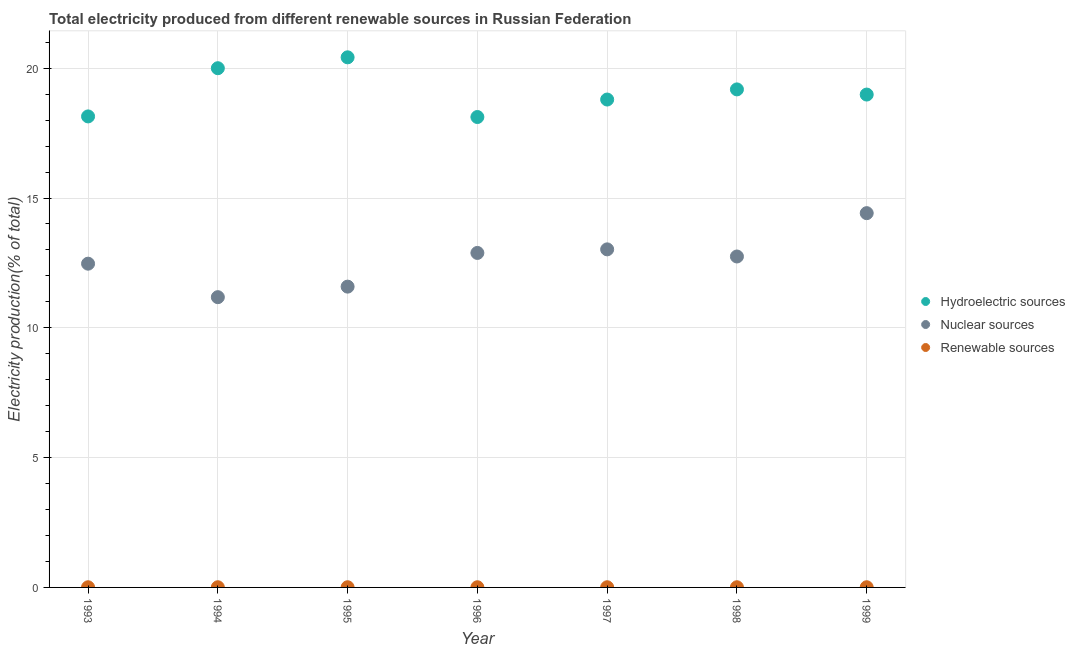Is the number of dotlines equal to the number of legend labels?
Provide a succinct answer. Yes. What is the percentage of electricity produced by renewable sources in 1993?
Make the answer very short. 0.01. Across all years, what is the maximum percentage of electricity produced by nuclear sources?
Keep it short and to the point. 14.42. Across all years, what is the minimum percentage of electricity produced by hydroelectric sources?
Your response must be concise. 18.12. In which year was the percentage of electricity produced by hydroelectric sources minimum?
Your answer should be very brief. 1996. What is the total percentage of electricity produced by nuclear sources in the graph?
Give a very brief answer. 88.31. What is the difference between the percentage of electricity produced by nuclear sources in 1995 and that in 1999?
Your response must be concise. -2.83. What is the difference between the percentage of electricity produced by hydroelectric sources in 1998 and the percentage of electricity produced by nuclear sources in 1995?
Your answer should be very brief. 7.6. What is the average percentage of electricity produced by nuclear sources per year?
Provide a short and direct response. 12.62. In the year 1999, what is the difference between the percentage of electricity produced by nuclear sources and percentage of electricity produced by renewable sources?
Your answer should be compact. 14.41. What is the ratio of the percentage of electricity produced by nuclear sources in 1993 to that in 1999?
Provide a short and direct response. 0.87. Is the percentage of electricity produced by hydroelectric sources in 1997 less than that in 1999?
Provide a short and direct response. Yes. What is the difference between the highest and the second highest percentage of electricity produced by nuclear sources?
Provide a short and direct response. 1.39. What is the difference between the highest and the lowest percentage of electricity produced by nuclear sources?
Make the answer very short. 3.24. Is the sum of the percentage of electricity produced by hydroelectric sources in 1994 and 1999 greater than the maximum percentage of electricity produced by nuclear sources across all years?
Keep it short and to the point. Yes. Is the percentage of electricity produced by renewable sources strictly greater than the percentage of electricity produced by nuclear sources over the years?
Your answer should be very brief. No. Is the percentage of electricity produced by nuclear sources strictly less than the percentage of electricity produced by hydroelectric sources over the years?
Your response must be concise. Yes. Does the graph contain any zero values?
Ensure brevity in your answer.  No. Does the graph contain grids?
Offer a terse response. Yes. How are the legend labels stacked?
Your answer should be very brief. Vertical. What is the title of the graph?
Give a very brief answer. Total electricity produced from different renewable sources in Russian Federation. What is the label or title of the X-axis?
Keep it short and to the point. Year. What is the label or title of the Y-axis?
Keep it short and to the point. Electricity production(% of total). What is the Electricity production(% of total) of Hydroelectric sources in 1993?
Keep it short and to the point. 18.14. What is the Electricity production(% of total) of Nuclear sources in 1993?
Your answer should be very brief. 12.47. What is the Electricity production(% of total) of Renewable sources in 1993?
Provide a succinct answer. 0.01. What is the Electricity production(% of total) in Hydroelectric sources in 1994?
Your answer should be very brief. 20. What is the Electricity production(% of total) in Nuclear sources in 1994?
Offer a very short reply. 11.18. What is the Electricity production(% of total) in Renewable sources in 1994?
Make the answer very short. 0.01. What is the Electricity production(% of total) of Hydroelectric sources in 1995?
Give a very brief answer. 20.42. What is the Electricity production(% of total) of Nuclear sources in 1995?
Your response must be concise. 11.59. What is the Electricity production(% of total) of Renewable sources in 1995?
Your answer should be very brief. 0.01. What is the Electricity production(% of total) in Hydroelectric sources in 1996?
Give a very brief answer. 18.12. What is the Electricity production(% of total) of Nuclear sources in 1996?
Make the answer very short. 12.88. What is the Electricity production(% of total) of Renewable sources in 1996?
Provide a short and direct response. 0.01. What is the Electricity production(% of total) in Hydroelectric sources in 1997?
Give a very brief answer. 18.79. What is the Electricity production(% of total) in Nuclear sources in 1997?
Offer a very short reply. 13.02. What is the Electricity production(% of total) of Renewable sources in 1997?
Offer a very short reply. 0.01. What is the Electricity production(% of total) of Hydroelectric sources in 1998?
Provide a succinct answer. 19.18. What is the Electricity production(% of total) in Nuclear sources in 1998?
Offer a very short reply. 12.75. What is the Electricity production(% of total) in Renewable sources in 1998?
Provide a succinct answer. 0.01. What is the Electricity production(% of total) of Hydroelectric sources in 1999?
Make the answer very short. 18.99. What is the Electricity production(% of total) in Nuclear sources in 1999?
Offer a very short reply. 14.42. What is the Electricity production(% of total) in Renewable sources in 1999?
Offer a terse response. 0.01. Across all years, what is the maximum Electricity production(% of total) of Hydroelectric sources?
Offer a very short reply. 20.42. Across all years, what is the maximum Electricity production(% of total) in Nuclear sources?
Provide a succinct answer. 14.42. Across all years, what is the maximum Electricity production(% of total) of Renewable sources?
Make the answer very short. 0.01. Across all years, what is the minimum Electricity production(% of total) of Hydroelectric sources?
Provide a short and direct response. 18.12. Across all years, what is the minimum Electricity production(% of total) of Nuclear sources?
Your response must be concise. 11.18. Across all years, what is the minimum Electricity production(% of total) of Renewable sources?
Give a very brief answer. 0.01. What is the total Electricity production(% of total) in Hydroelectric sources in the graph?
Provide a short and direct response. 133.65. What is the total Electricity production(% of total) of Nuclear sources in the graph?
Ensure brevity in your answer.  88.31. What is the total Electricity production(% of total) in Renewable sources in the graph?
Offer a very short reply. 0.05. What is the difference between the Electricity production(% of total) of Hydroelectric sources in 1993 and that in 1994?
Offer a terse response. -1.86. What is the difference between the Electricity production(% of total) in Nuclear sources in 1993 and that in 1994?
Make the answer very short. 1.29. What is the difference between the Electricity production(% of total) in Renewable sources in 1993 and that in 1994?
Ensure brevity in your answer.  -0. What is the difference between the Electricity production(% of total) of Hydroelectric sources in 1993 and that in 1995?
Your answer should be compact. -2.28. What is the difference between the Electricity production(% of total) of Nuclear sources in 1993 and that in 1995?
Ensure brevity in your answer.  0.88. What is the difference between the Electricity production(% of total) in Renewable sources in 1993 and that in 1995?
Provide a succinct answer. -0. What is the difference between the Electricity production(% of total) of Hydroelectric sources in 1993 and that in 1996?
Provide a succinct answer. 0.02. What is the difference between the Electricity production(% of total) in Nuclear sources in 1993 and that in 1996?
Your response must be concise. -0.41. What is the difference between the Electricity production(% of total) in Renewable sources in 1993 and that in 1996?
Ensure brevity in your answer.  -0. What is the difference between the Electricity production(% of total) in Hydroelectric sources in 1993 and that in 1997?
Offer a very short reply. -0.65. What is the difference between the Electricity production(% of total) of Nuclear sources in 1993 and that in 1997?
Make the answer very short. -0.55. What is the difference between the Electricity production(% of total) in Renewable sources in 1993 and that in 1997?
Your answer should be compact. -0. What is the difference between the Electricity production(% of total) of Hydroelectric sources in 1993 and that in 1998?
Offer a terse response. -1.04. What is the difference between the Electricity production(% of total) in Nuclear sources in 1993 and that in 1998?
Provide a short and direct response. -0.28. What is the difference between the Electricity production(% of total) in Renewable sources in 1993 and that in 1998?
Offer a terse response. -0. What is the difference between the Electricity production(% of total) of Hydroelectric sources in 1993 and that in 1999?
Offer a very short reply. -0.84. What is the difference between the Electricity production(% of total) in Nuclear sources in 1993 and that in 1999?
Offer a terse response. -1.95. What is the difference between the Electricity production(% of total) of Renewable sources in 1993 and that in 1999?
Ensure brevity in your answer.  -0. What is the difference between the Electricity production(% of total) in Hydroelectric sources in 1994 and that in 1995?
Your answer should be very brief. -0.42. What is the difference between the Electricity production(% of total) of Nuclear sources in 1994 and that in 1995?
Your answer should be very brief. -0.41. What is the difference between the Electricity production(% of total) of Renewable sources in 1994 and that in 1995?
Provide a short and direct response. 0. What is the difference between the Electricity production(% of total) of Hydroelectric sources in 1994 and that in 1996?
Your answer should be very brief. 1.88. What is the difference between the Electricity production(% of total) in Nuclear sources in 1994 and that in 1996?
Keep it short and to the point. -1.7. What is the difference between the Electricity production(% of total) of Hydroelectric sources in 1994 and that in 1997?
Keep it short and to the point. 1.21. What is the difference between the Electricity production(% of total) of Nuclear sources in 1994 and that in 1997?
Give a very brief answer. -1.84. What is the difference between the Electricity production(% of total) in Hydroelectric sources in 1994 and that in 1998?
Make the answer very short. 0.82. What is the difference between the Electricity production(% of total) in Nuclear sources in 1994 and that in 1998?
Give a very brief answer. -1.57. What is the difference between the Electricity production(% of total) of Hydroelectric sources in 1994 and that in 1999?
Your answer should be compact. 1.01. What is the difference between the Electricity production(% of total) in Nuclear sources in 1994 and that in 1999?
Your response must be concise. -3.24. What is the difference between the Electricity production(% of total) of Renewable sources in 1994 and that in 1999?
Give a very brief answer. -0. What is the difference between the Electricity production(% of total) of Hydroelectric sources in 1995 and that in 1996?
Give a very brief answer. 2.3. What is the difference between the Electricity production(% of total) in Nuclear sources in 1995 and that in 1996?
Give a very brief answer. -1.3. What is the difference between the Electricity production(% of total) of Hydroelectric sources in 1995 and that in 1997?
Offer a very short reply. 1.63. What is the difference between the Electricity production(% of total) of Nuclear sources in 1995 and that in 1997?
Keep it short and to the point. -1.44. What is the difference between the Electricity production(% of total) in Renewable sources in 1995 and that in 1997?
Provide a succinct answer. 0. What is the difference between the Electricity production(% of total) in Hydroelectric sources in 1995 and that in 1998?
Your answer should be very brief. 1.24. What is the difference between the Electricity production(% of total) of Nuclear sources in 1995 and that in 1998?
Keep it short and to the point. -1.16. What is the difference between the Electricity production(% of total) in Renewable sources in 1995 and that in 1998?
Provide a short and direct response. -0. What is the difference between the Electricity production(% of total) of Hydroelectric sources in 1995 and that in 1999?
Offer a terse response. 1.43. What is the difference between the Electricity production(% of total) in Nuclear sources in 1995 and that in 1999?
Ensure brevity in your answer.  -2.83. What is the difference between the Electricity production(% of total) of Renewable sources in 1995 and that in 1999?
Your answer should be very brief. -0. What is the difference between the Electricity production(% of total) of Hydroelectric sources in 1996 and that in 1997?
Offer a terse response. -0.67. What is the difference between the Electricity production(% of total) in Nuclear sources in 1996 and that in 1997?
Your response must be concise. -0.14. What is the difference between the Electricity production(% of total) in Renewable sources in 1996 and that in 1997?
Provide a short and direct response. -0. What is the difference between the Electricity production(% of total) of Hydroelectric sources in 1996 and that in 1998?
Your answer should be compact. -1.06. What is the difference between the Electricity production(% of total) in Nuclear sources in 1996 and that in 1998?
Make the answer very short. 0.14. What is the difference between the Electricity production(% of total) in Renewable sources in 1996 and that in 1998?
Provide a succinct answer. -0. What is the difference between the Electricity production(% of total) in Hydroelectric sources in 1996 and that in 1999?
Your answer should be very brief. -0.86. What is the difference between the Electricity production(% of total) of Nuclear sources in 1996 and that in 1999?
Make the answer very short. -1.53. What is the difference between the Electricity production(% of total) of Renewable sources in 1996 and that in 1999?
Provide a short and direct response. -0. What is the difference between the Electricity production(% of total) of Hydroelectric sources in 1997 and that in 1998?
Offer a very short reply. -0.39. What is the difference between the Electricity production(% of total) of Nuclear sources in 1997 and that in 1998?
Make the answer very short. 0.27. What is the difference between the Electricity production(% of total) in Renewable sources in 1997 and that in 1998?
Your response must be concise. -0. What is the difference between the Electricity production(% of total) in Hydroelectric sources in 1997 and that in 1999?
Offer a very short reply. -0.19. What is the difference between the Electricity production(% of total) in Nuclear sources in 1997 and that in 1999?
Provide a succinct answer. -1.39. What is the difference between the Electricity production(% of total) of Renewable sources in 1997 and that in 1999?
Your answer should be very brief. -0. What is the difference between the Electricity production(% of total) in Hydroelectric sources in 1998 and that in 1999?
Your answer should be compact. 0.2. What is the difference between the Electricity production(% of total) in Nuclear sources in 1998 and that in 1999?
Give a very brief answer. -1.67. What is the difference between the Electricity production(% of total) of Renewable sources in 1998 and that in 1999?
Make the answer very short. -0. What is the difference between the Electricity production(% of total) of Hydroelectric sources in 1993 and the Electricity production(% of total) of Nuclear sources in 1994?
Give a very brief answer. 6.96. What is the difference between the Electricity production(% of total) of Hydroelectric sources in 1993 and the Electricity production(% of total) of Renewable sources in 1994?
Keep it short and to the point. 18.14. What is the difference between the Electricity production(% of total) in Nuclear sources in 1993 and the Electricity production(% of total) in Renewable sources in 1994?
Your answer should be very brief. 12.46. What is the difference between the Electricity production(% of total) in Hydroelectric sources in 1993 and the Electricity production(% of total) in Nuclear sources in 1995?
Make the answer very short. 6.56. What is the difference between the Electricity production(% of total) in Hydroelectric sources in 1993 and the Electricity production(% of total) in Renewable sources in 1995?
Provide a short and direct response. 18.14. What is the difference between the Electricity production(% of total) of Nuclear sources in 1993 and the Electricity production(% of total) of Renewable sources in 1995?
Provide a short and direct response. 12.46. What is the difference between the Electricity production(% of total) of Hydroelectric sources in 1993 and the Electricity production(% of total) of Nuclear sources in 1996?
Your response must be concise. 5.26. What is the difference between the Electricity production(% of total) in Hydroelectric sources in 1993 and the Electricity production(% of total) in Renewable sources in 1996?
Your answer should be compact. 18.14. What is the difference between the Electricity production(% of total) in Nuclear sources in 1993 and the Electricity production(% of total) in Renewable sources in 1996?
Your answer should be very brief. 12.46. What is the difference between the Electricity production(% of total) in Hydroelectric sources in 1993 and the Electricity production(% of total) in Nuclear sources in 1997?
Ensure brevity in your answer.  5.12. What is the difference between the Electricity production(% of total) of Hydroelectric sources in 1993 and the Electricity production(% of total) of Renewable sources in 1997?
Your answer should be compact. 18.14. What is the difference between the Electricity production(% of total) in Nuclear sources in 1993 and the Electricity production(% of total) in Renewable sources in 1997?
Ensure brevity in your answer.  12.46. What is the difference between the Electricity production(% of total) in Hydroelectric sources in 1993 and the Electricity production(% of total) in Nuclear sources in 1998?
Make the answer very short. 5.4. What is the difference between the Electricity production(% of total) in Hydroelectric sources in 1993 and the Electricity production(% of total) in Renewable sources in 1998?
Provide a succinct answer. 18.14. What is the difference between the Electricity production(% of total) in Nuclear sources in 1993 and the Electricity production(% of total) in Renewable sources in 1998?
Provide a short and direct response. 12.46. What is the difference between the Electricity production(% of total) of Hydroelectric sources in 1993 and the Electricity production(% of total) of Nuclear sources in 1999?
Your answer should be very brief. 3.73. What is the difference between the Electricity production(% of total) in Hydroelectric sources in 1993 and the Electricity production(% of total) in Renewable sources in 1999?
Provide a succinct answer. 18.14. What is the difference between the Electricity production(% of total) of Nuclear sources in 1993 and the Electricity production(% of total) of Renewable sources in 1999?
Make the answer very short. 12.46. What is the difference between the Electricity production(% of total) of Hydroelectric sources in 1994 and the Electricity production(% of total) of Nuclear sources in 1995?
Give a very brief answer. 8.41. What is the difference between the Electricity production(% of total) in Hydroelectric sources in 1994 and the Electricity production(% of total) in Renewable sources in 1995?
Your answer should be very brief. 19.99. What is the difference between the Electricity production(% of total) of Nuclear sources in 1994 and the Electricity production(% of total) of Renewable sources in 1995?
Ensure brevity in your answer.  11.17. What is the difference between the Electricity production(% of total) of Hydroelectric sources in 1994 and the Electricity production(% of total) of Nuclear sources in 1996?
Ensure brevity in your answer.  7.12. What is the difference between the Electricity production(% of total) in Hydroelectric sources in 1994 and the Electricity production(% of total) in Renewable sources in 1996?
Provide a succinct answer. 19.99. What is the difference between the Electricity production(% of total) of Nuclear sources in 1994 and the Electricity production(% of total) of Renewable sources in 1996?
Give a very brief answer. 11.17. What is the difference between the Electricity production(% of total) of Hydroelectric sources in 1994 and the Electricity production(% of total) of Nuclear sources in 1997?
Your answer should be very brief. 6.98. What is the difference between the Electricity production(% of total) in Hydroelectric sources in 1994 and the Electricity production(% of total) in Renewable sources in 1997?
Your answer should be compact. 19.99. What is the difference between the Electricity production(% of total) of Nuclear sources in 1994 and the Electricity production(% of total) of Renewable sources in 1997?
Make the answer very short. 11.17. What is the difference between the Electricity production(% of total) in Hydroelectric sources in 1994 and the Electricity production(% of total) in Nuclear sources in 1998?
Provide a short and direct response. 7.25. What is the difference between the Electricity production(% of total) in Hydroelectric sources in 1994 and the Electricity production(% of total) in Renewable sources in 1998?
Offer a terse response. 19.99. What is the difference between the Electricity production(% of total) of Nuclear sources in 1994 and the Electricity production(% of total) of Renewable sources in 1998?
Make the answer very short. 11.17. What is the difference between the Electricity production(% of total) of Hydroelectric sources in 1994 and the Electricity production(% of total) of Nuclear sources in 1999?
Make the answer very short. 5.58. What is the difference between the Electricity production(% of total) in Hydroelectric sources in 1994 and the Electricity production(% of total) in Renewable sources in 1999?
Keep it short and to the point. 19.99. What is the difference between the Electricity production(% of total) in Nuclear sources in 1994 and the Electricity production(% of total) in Renewable sources in 1999?
Offer a terse response. 11.17. What is the difference between the Electricity production(% of total) in Hydroelectric sources in 1995 and the Electricity production(% of total) in Nuclear sources in 1996?
Keep it short and to the point. 7.54. What is the difference between the Electricity production(% of total) of Hydroelectric sources in 1995 and the Electricity production(% of total) of Renewable sources in 1996?
Your answer should be compact. 20.41. What is the difference between the Electricity production(% of total) in Nuclear sources in 1995 and the Electricity production(% of total) in Renewable sources in 1996?
Ensure brevity in your answer.  11.58. What is the difference between the Electricity production(% of total) of Hydroelectric sources in 1995 and the Electricity production(% of total) of Nuclear sources in 1997?
Your answer should be very brief. 7.4. What is the difference between the Electricity production(% of total) of Hydroelectric sources in 1995 and the Electricity production(% of total) of Renewable sources in 1997?
Provide a succinct answer. 20.41. What is the difference between the Electricity production(% of total) of Nuclear sources in 1995 and the Electricity production(% of total) of Renewable sources in 1997?
Your answer should be compact. 11.58. What is the difference between the Electricity production(% of total) of Hydroelectric sources in 1995 and the Electricity production(% of total) of Nuclear sources in 1998?
Give a very brief answer. 7.67. What is the difference between the Electricity production(% of total) in Hydroelectric sources in 1995 and the Electricity production(% of total) in Renewable sources in 1998?
Ensure brevity in your answer.  20.41. What is the difference between the Electricity production(% of total) in Nuclear sources in 1995 and the Electricity production(% of total) in Renewable sources in 1998?
Provide a short and direct response. 11.58. What is the difference between the Electricity production(% of total) in Hydroelectric sources in 1995 and the Electricity production(% of total) in Nuclear sources in 1999?
Give a very brief answer. 6. What is the difference between the Electricity production(% of total) of Hydroelectric sources in 1995 and the Electricity production(% of total) of Renewable sources in 1999?
Give a very brief answer. 20.41. What is the difference between the Electricity production(% of total) of Nuclear sources in 1995 and the Electricity production(% of total) of Renewable sources in 1999?
Keep it short and to the point. 11.58. What is the difference between the Electricity production(% of total) in Hydroelectric sources in 1996 and the Electricity production(% of total) in Nuclear sources in 1997?
Make the answer very short. 5.1. What is the difference between the Electricity production(% of total) of Hydroelectric sources in 1996 and the Electricity production(% of total) of Renewable sources in 1997?
Keep it short and to the point. 18.11. What is the difference between the Electricity production(% of total) of Nuclear sources in 1996 and the Electricity production(% of total) of Renewable sources in 1997?
Ensure brevity in your answer.  12.88. What is the difference between the Electricity production(% of total) in Hydroelectric sources in 1996 and the Electricity production(% of total) in Nuclear sources in 1998?
Your answer should be compact. 5.37. What is the difference between the Electricity production(% of total) of Hydroelectric sources in 1996 and the Electricity production(% of total) of Renewable sources in 1998?
Give a very brief answer. 18.11. What is the difference between the Electricity production(% of total) in Nuclear sources in 1996 and the Electricity production(% of total) in Renewable sources in 1998?
Provide a succinct answer. 12.88. What is the difference between the Electricity production(% of total) in Hydroelectric sources in 1996 and the Electricity production(% of total) in Nuclear sources in 1999?
Offer a terse response. 3.7. What is the difference between the Electricity production(% of total) in Hydroelectric sources in 1996 and the Electricity production(% of total) in Renewable sources in 1999?
Provide a short and direct response. 18.11. What is the difference between the Electricity production(% of total) in Nuclear sources in 1996 and the Electricity production(% of total) in Renewable sources in 1999?
Provide a short and direct response. 12.88. What is the difference between the Electricity production(% of total) of Hydroelectric sources in 1997 and the Electricity production(% of total) of Nuclear sources in 1998?
Your response must be concise. 6.05. What is the difference between the Electricity production(% of total) of Hydroelectric sources in 1997 and the Electricity production(% of total) of Renewable sources in 1998?
Provide a succinct answer. 18.79. What is the difference between the Electricity production(% of total) of Nuclear sources in 1997 and the Electricity production(% of total) of Renewable sources in 1998?
Give a very brief answer. 13.02. What is the difference between the Electricity production(% of total) of Hydroelectric sources in 1997 and the Electricity production(% of total) of Nuclear sources in 1999?
Your response must be concise. 4.38. What is the difference between the Electricity production(% of total) in Hydroelectric sources in 1997 and the Electricity production(% of total) in Renewable sources in 1999?
Your response must be concise. 18.79. What is the difference between the Electricity production(% of total) of Nuclear sources in 1997 and the Electricity production(% of total) of Renewable sources in 1999?
Make the answer very short. 13.02. What is the difference between the Electricity production(% of total) in Hydroelectric sources in 1998 and the Electricity production(% of total) in Nuclear sources in 1999?
Offer a very short reply. 4.77. What is the difference between the Electricity production(% of total) in Hydroelectric sources in 1998 and the Electricity production(% of total) in Renewable sources in 1999?
Make the answer very short. 19.18. What is the difference between the Electricity production(% of total) of Nuclear sources in 1998 and the Electricity production(% of total) of Renewable sources in 1999?
Ensure brevity in your answer.  12.74. What is the average Electricity production(% of total) of Hydroelectric sources per year?
Keep it short and to the point. 19.09. What is the average Electricity production(% of total) in Nuclear sources per year?
Keep it short and to the point. 12.62. What is the average Electricity production(% of total) in Renewable sources per year?
Offer a terse response. 0.01. In the year 1993, what is the difference between the Electricity production(% of total) in Hydroelectric sources and Electricity production(% of total) in Nuclear sources?
Your response must be concise. 5.67. In the year 1993, what is the difference between the Electricity production(% of total) of Hydroelectric sources and Electricity production(% of total) of Renewable sources?
Provide a short and direct response. 18.14. In the year 1993, what is the difference between the Electricity production(% of total) of Nuclear sources and Electricity production(% of total) of Renewable sources?
Offer a very short reply. 12.46. In the year 1994, what is the difference between the Electricity production(% of total) in Hydroelectric sources and Electricity production(% of total) in Nuclear sources?
Your answer should be compact. 8.82. In the year 1994, what is the difference between the Electricity production(% of total) of Hydroelectric sources and Electricity production(% of total) of Renewable sources?
Your response must be concise. 19.99. In the year 1994, what is the difference between the Electricity production(% of total) of Nuclear sources and Electricity production(% of total) of Renewable sources?
Provide a succinct answer. 11.17. In the year 1995, what is the difference between the Electricity production(% of total) of Hydroelectric sources and Electricity production(% of total) of Nuclear sources?
Provide a succinct answer. 8.83. In the year 1995, what is the difference between the Electricity production(% of total) in Hydroelectric sources and Electricity production(% of total) in Renewable sources?
Give a very brief answer. 20.41. In the year 1995, what is the difference between the Electricity production(% of total) in Nuclear sources and Electricity production(% of total) in Renewable sources?
Ensure brevity in your answer.  11.58. In the year 1996, what is the difference between the Electricity production(% of total) in Hydroelectric sources and Electricity production(% of total) in Nuclear sources?
Your answer should be compact. 5.24. In the year 1996, what is the difference between the Electricity production(% of total) in Hydroelectric sources and Electricity production(% of total) in Renewable sources?
Provide a succinct answer. 18.11. In the year 1996, what is the difference between the Electricity production(% of total) of Nuclear sources and Electricity production(% of total) of Renewable sources?
Offer a very short reply. 12.88. In the year 1997, what is the difference between the Electricity production(% of total) in Hydroelectric sources and Electricity production(% of total) in Nuclear sources?
Your answer should be very brief. 5.77. In the year 1997, what is the difference between the Electricity production(% of total) of Hydroelectric sources and Electricity production(% of total) of Renewable sources?
Keep it short and to the point. 18.79. In the year 1997, what is the difference between the Electricity production(% of total) in Nuclear sources and Electricity production(% of total) in Renewable sources?
Offer a terse response. 13.02. In the year 1998, what is the difference between the Electricity production(% of total) in Hydroelectric sources and Electricity production(% of total) in Nuclear sources?
Your response must be concise. 6.44. In the year 1998, what is the difference between the Electricity production(% of total) of Hydroelectric sources and Electricity production(% of total) of Renewable sources?
Make the answer very short. 19.18. In the year 1998, what is the difference between the Electricity production(% of total) of Nuclear sources and Electricity production(% of total) of Renewable sources?
Ensure brevity in your answer.  12.74. In the year 1999, what is the difference between the Electricity production(% of total) of Hydroelectric sources and Electricity production(% of total) of Nuclear sources?
Provide a short and direct response. 4.57. In the year 1999, what is the difference between the Electricity production(% of total) in Hydroelectric sources and Electricity production(% of total) in Renewable sources?
Offer a terse response. 18.98. In the year 1999, what is the difference between the Electricity production(% of total) of Nuclear sources and Electricity production(% of total) of Renewable sources?
Your response must be concise. 14.41. What is the ratio of the Electricity production(% of total) of Hydroelectric sources in 1993 to that in 1994?
Keep it short and to the point. 0.91. What is the ratio of the Electricity production(% of total) in Nuclear sources in 1993 to that in 1994?
Give a very brief answer. 1.12. What is the ratio of the Electricity production(% of total) in Renewable sources in 1993 to that in 1994?
Offer a very short reply. 0.9. What is the ratio of the Electricity production(% of total) in Hydroelectric sources in 1993 to that in 1995?
Keep it short and to the point. 0.89. What is the ratio of the Electricity production(% of total) in Nuclear sources in 1993 to that in 1995?
Ensure brevity in your answer.  1.08. What is the ratio of the Electricity production(% of total) of Renewable sources in 1993 to that in 1995?
Ensure brevity in your answer.  0.91. What is the ratio of the Electricity production(% of total) of Nuclear sources in 1993 to that in 1996?
Keep it short and to the point. 0.97. What is the ratio of the Electricity production(% of total) of Renewable sources in 1993 to that in 1996?
Ensure brevity in your answer.  0.93. What is the ratio of the Electricity production(% of total) of Hydroelectric sources in 1993 to that in 1997?
Keep it short and to the point. 0.97. What is the ratio of the Electricity production(% of total) in Nuclear sources in 1993 to that in 1997?
Provide a succinct answer. 0.96. What is the ratio of the Electricity production(% of total) of Renewable sources in 1993 to that in 1997?
Provide a short and direct response. 0.92. What is the ratio of the Electricity production(% of total) in Hydroelectric sources in 1993 to that in 1998?
Keep it short and to the point. 0.95. What is the ratio of the Electricity production(% of total) in Nuclear sources in 1993 to that in 1998?
Keep it short and to the point. 0.98. What is the ratio of the Electricity production(% of total) in Renewable sources in 1993 to that in 1998?
Offer a very short reply. 0.89. What is the ratio of the Electricity production(% of total) of Hydroelectric sources in 1993 to that in 1999?
Your answer should be very brief. 0.96. What is the ratio of the Electricity production(% of total) of Nuclear sources in 1993 to that in 1999?
Your answer should be very brief. 0.86. What is the ratio of the Electricity production(% of total) in Renewable sources in 1993 to that in 1999?
Your answer should be compact. 0.88. What is the ratio of the Electricity production(% of total) of Hydroelectric sources in 1994 to that in 1995?
Make the answer very short. 0.98. What is the ratio of the Electricity production(% of total) in Nuclear sources in 1994 to that in 1995?
Make the answer very short. 0.96. What is the ratio of the Electricity production(% of total) of Renewable sources in 1994 to that in 1995?
Provide a short and direct response. 1.02. What is the ratio of the Electricity production(% of total) in Hydroelectric sources in 1994 to that in 1996?
Offer a very short reply. 1.1. What is the ratio of the Electricity production(% of total) in Nuclear sources in 1994 to that in 1996?
Give a very brief answer. 0.87. What is the ratio of the Electricity production(% of total) in Renewable sources in 1994 to that in 1996?
Your answer should be compact. 1.04. What is the ratio of the Electricity production(% of total) in Hydroelectric sources in 1994 to that in 1997?
Your response must be concise. 1.06. What is the ratio of the Electricity production(% of total) in Nuclear sources in 1994 to that in 1997?
Provide a succinct answer. 0.86. What is the ratio of the Electricity production(% of total) in Renewable sources in 1994 to that in 1997?
Give a very brief answer. 1.02. What is the ratio of the Electricity production(% of total) in Hydroelectric sources in 1994 to that in 1998?
Your answer should be compact. 1.04. What is the ratio of the Electricity production(% of total) of Nuclear sources in 1994 to that in 1998?
Give a very brief answer. 0.88. What is the ratio of the Electricity production(% of total) in Hydroelectric sources in 1994 to that in 1999?
Give a very brief answer. 1.05. What is the ratio of the Electricity production(% of total) of Nuclear sources in 1994 to that in 1999?
Make the answer very short. 0.78. What is the ratio of the Electricity production(% of total) of Renewable sources in 1994 to that in 1999?
Your response must be concise. 0.98. What is the ratio of the Electricity production(% of total) in Hydroelectric sources in 1995 to that in 1996?
Give a very brief answer. 1.13. What is the ratio of the Electricity production(% of total) of Nuclear sources in 1995 to that in 1996?
Your response must be concise. 0.9. What is the ratio of the Electricity production(% of total) in Renewable sources in 1995 to that in 1996?
Make the answer very short. 1.02. What is the ratio of the Electricity production(% of total) in Hydroelectric sources in 1995 to that in 1997?
Ensure brevity in your answer.  1.09. What is the ratio of the Electricity production(% of total) in Nuclear sources in 1995 to that in 1997?
Make the answer very short. 0.89. What is the ratio of the Electricity production(% of total) in Hydroelectric sources in 1995 to that in 1998?
Your answer should be very brief. 1.06. What is the ratio of the Electricity production(% of total) in Nuclear sources in 1995 to that in 1998?
Keep it short and to the point. 0.91. What is the ratio of the Electricity production(% of total) of Renewable sources in 1995 to that in 1998?
Your answer should be compact. 0.98. What is the ratio of the Electricity production(% of total) of Hydroelectric sources in 1995 to that in 1999?
Your answer should be very brief. 1.08. What is the ratio of the Electricity production(% of total) of Nuclear sources in 1995 to that in 1999?
Your answer should be very brief. 0.8. What is the ratio of the Electricity production(% of total) of Renewable sources in 1995 to that in 1999?
Ensure brevity in your answer.  0.97. What is the ratio of the Electricity production(% of total) of Hydroelectric sources in 1996 to that in 1997?
Give a very brief answer. 0.96. What is the ratio of the Electricity production(% of total) of Nuclear sources in 1996 to that in 1997?
Your answer should be compact. 0.99. What is the ratio of the Electricity production(% of total) in Renewable sources in 1996 to that in 1997?
Make the answer very short. 0.98. What is the ratio of the Electricity production(% of total) in Hydroelectric sources in 1996 to that in 1998?
Your answer should be compact. 0.94. What is the ratio of the Electricity production(% of total) in Nuclear sources in 1996 to that in 1998?
Keep it short and to the point. 1.01. What is the ratio of the Electricity production(% of total) in Renewable sources in 1996 to that in 1998?
Offer a very short reply. 0.96. What is the ratio of the Electricity production(% of total) of Hydroelectric sources in 1996 to that in 1999?
Provide a short and direct response. 0.95. What is the ratio of the Electricity production(% of total) of Nuclear sources in 1996 to that in 1999?
Keep it short and to the point. 0.89. What is the ratio of the Electricity production(% of total) of Renewable sources in 1996 to that in 1999?
Ensure brevity in your answer.  0.95. What is the ratio of the Electricity production(% of total) of Hydroelectric sources in 1997 to that in 1998?
Give a very brief answer. 0.98. What is the ratio of the Electricity production(% of total) in Nuclear sources in 1997 to that in 1998?
Ensure brevity in your answer.  1.02. What is the ratio of the Electricity production(% of total) of Renewable sources in 1997 to that in 1998?
Ensure brevity in your answer.  0.97. What is the ratio of the Electricity production(% of total) of Hydroelectric sources in 1997 to that in 1999?
Give a very brief answer. 0.99. What is the ratio of the Electricity production(% of total) of Nuclear sources in 1997 to that in 1999?
Your answer should be very brief. 0.9. What is the ratio of the Electricity production(% of total) in Renewable sources in 1997 to that in 1999?
Provide a short and direct response. 0.96. What is the ratio of the Electricity production(% of total) of Hydroelectric sources in 1998 to that in 1999?
Your answer should be compact. 1.01. What is the ratio of the Electricity production(% of total) in Nuclear sources in 1998 to that in 1999?
Keep it short and to the point. 0.88. What is the ratio of the Electricity production(% of total) of Renewable sources in 1998 to that in 1999?
Offer a very short reply. 0.99. What is the difference between the highest and the second highest Electricity production(% of total) of Hydroelectric sources?
Provide a succinct answer. 0.42. What is the difference between the highest and the second highest Electricity production(% of total) of Nuclear sources?
Keep it short and to the point. 1.39. What is the difference between the highest and the lowest Electricity production(% of total) in Hydroelectric sources?
Provide a succinct answer. 2.3. What is the difference between the highest and the lowest Electricity production(% of total) of Nuclear sources?
Ensure brevity in your answer.  3.24. What is the difference between the highest and the lowest Electricity production(% of total) of Renewable sources?
Keep it short and to the point. 0. 